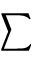<formula> <loc_0><loc_0><loc_500><loc_500>\sum</formula> 